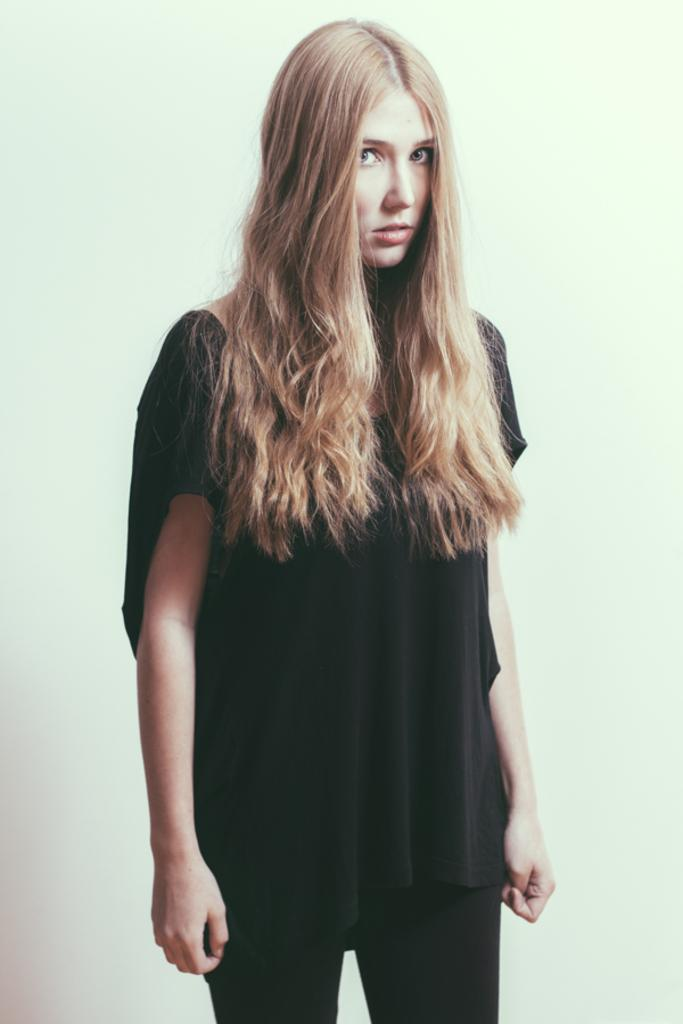What is the main subject of the image? There is a girl standing in the image. Can you describe the background of the image? There is a wall in the background of the image. What type of quince is the girl holding in the image? There is no quince present in the image. Can you see an airplane flying in the background of the image? There is no airplane visible in the image; it only features a girl standing in front of a wall. 